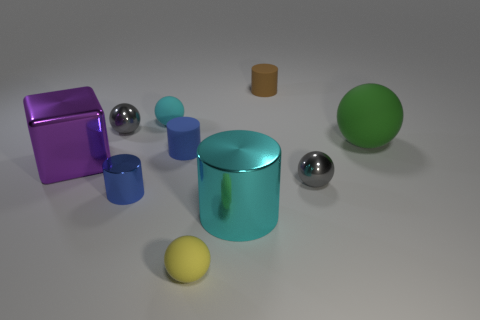Is there any other thing that has the same shape as the large purple thing?
Provide a succinct answer. No. Are there fewer gray shiny balls to the left of the small brown thing than tiny things in front of the shiny block?
Give a very brief answer. Yes. What is the color of the block that is the same material as the big cyan object?
Offer a very short reply. Purple. The big thing behind the blue cylinder that is behind the purple metal cube is what color?
Offer a terse response. Green. Is there a small sphere of the same color as the big cylinder?
Your answer should be compact. Yes. There is a green matte object that is the same size as the purple block; what is its shape?
Your answer should be compact. Sphere. There is a tiny gray metallic object that is right of the cyan cylinder; what number of tiny cylinders are right of it?
Your answer should be very brief. 0. What number of other things are made of the same material as the cube?
Your answer should be very brief. 4. There is a tiny gray thing in front of the big object that is on the left side of the cyan cylinder; what shape is it?
Your answer should be very brief. Sphere. What size is the rubber object to the right of the small brown rubber object?
Your response must be concise. Large. 